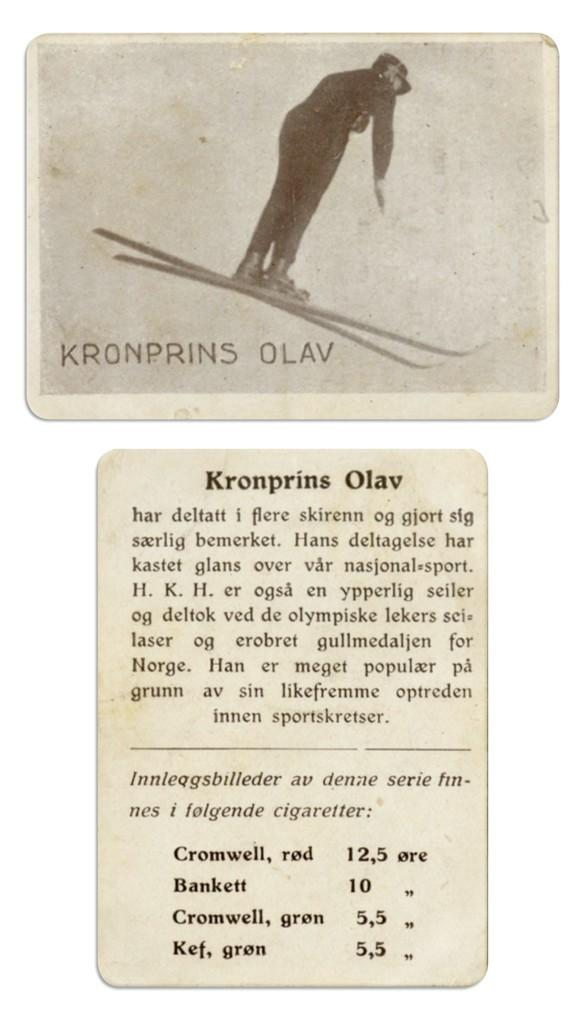How many papers can be seen in the image? There are two papers in the image. What is depicted on one of the papers? There is a picture of a man standing with ski boards on one of the papers. What else can be found on the paper besides the image? There are letters and numbers on the paper. What type of treatment is being administered to the man in the image? There is no indication in the image that the man is receiving any treatment; he is simply depicted standing with ski boards. 